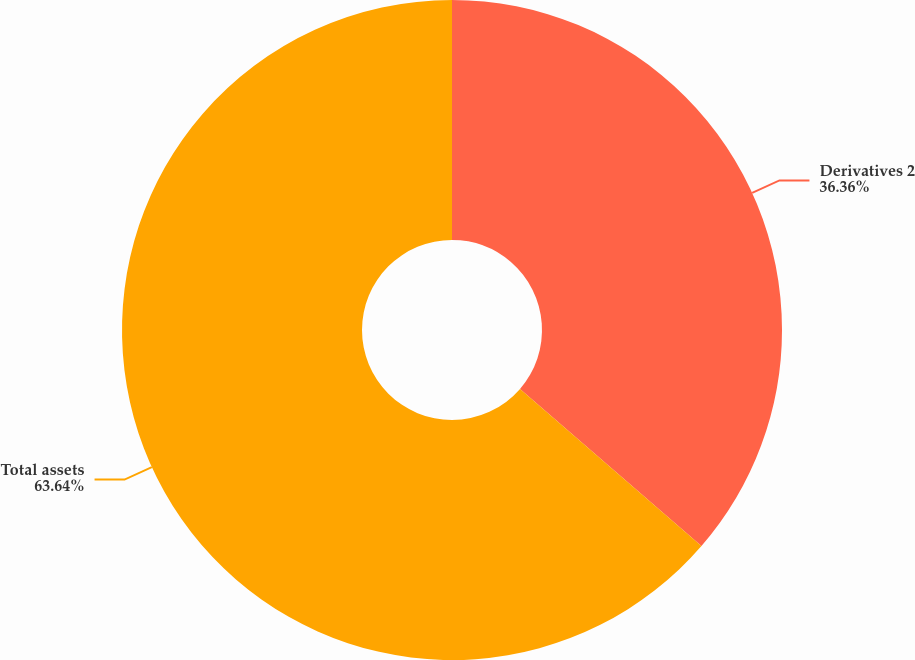Convert chart. <chart><loc_0><loc_0><loc_500><loc_500><pie_chart><fcel>Derivatives 2<fcel>Total assets<nl><fcel>36.36%<fcel>63.64%<nl></chart> 